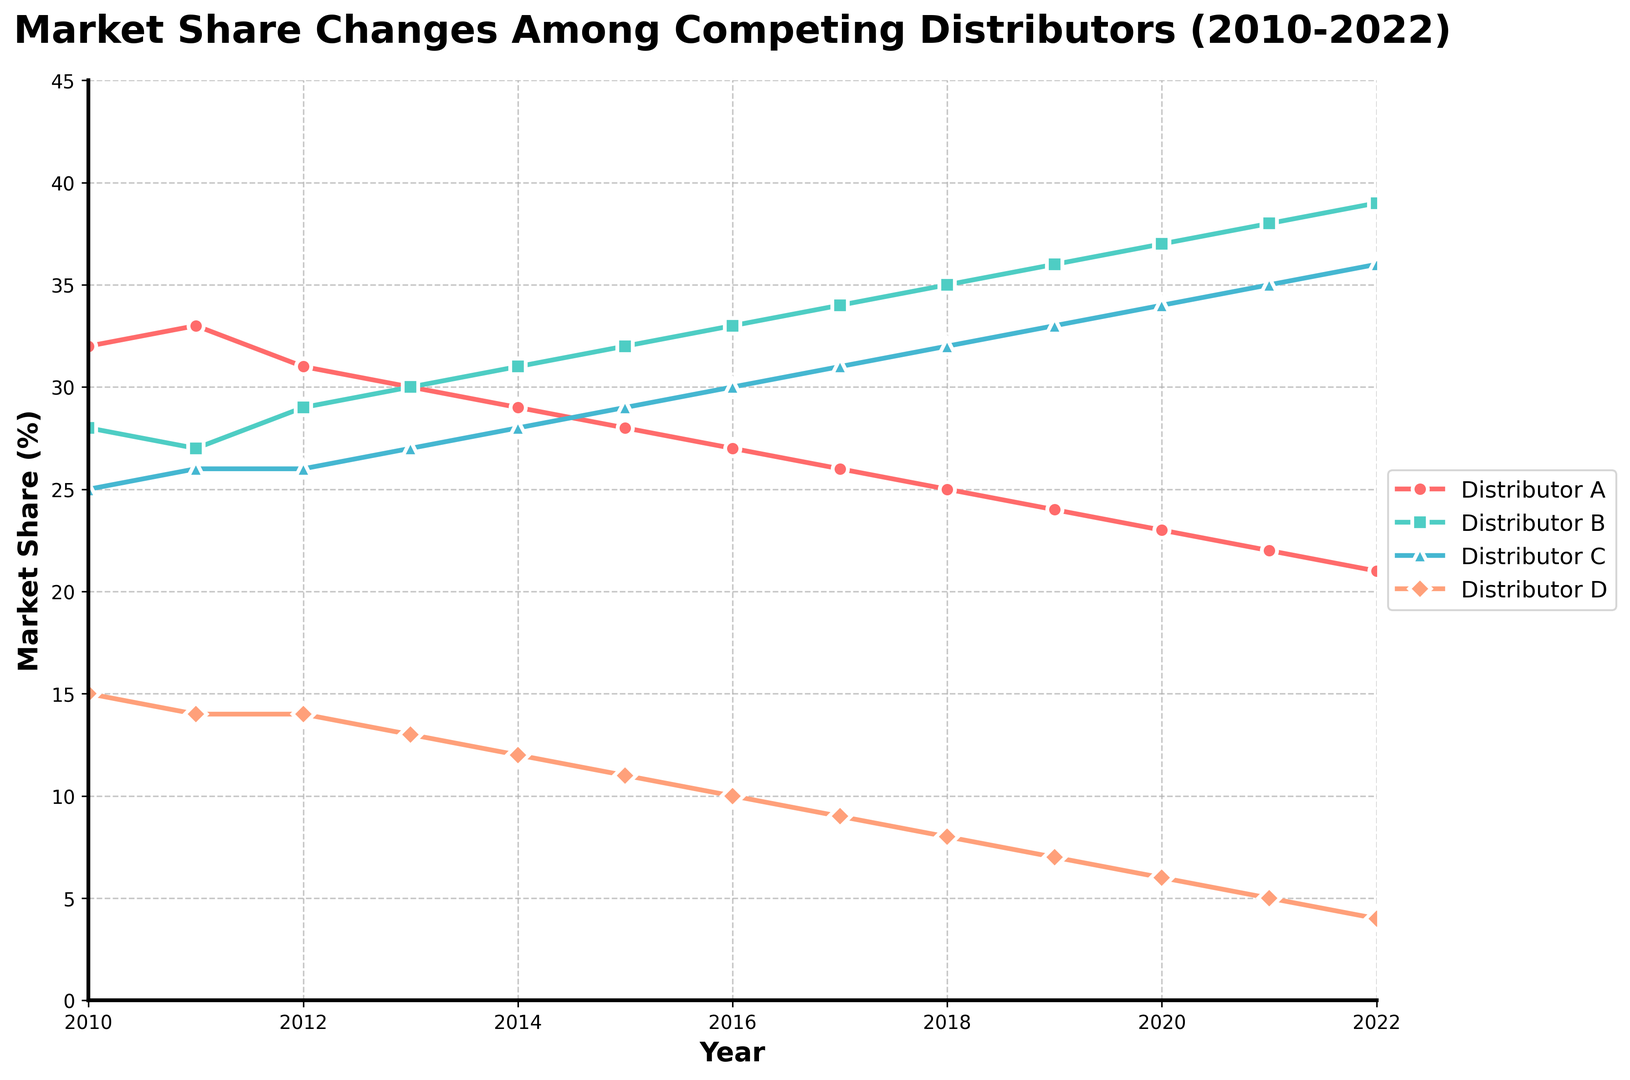What was the market share trend for Distributor A between 2010 and 2022? Distributor A's market share started at 32% in 2010 and consistently decreased each year until it reached 21% in 2022.
Answer: Consistently decreasing Which distributor had the highest market share in 2013, and what was the value? In 2013, Distributor B had the highest market share, with a value of 30%.
Answer: Distributor B, 30% Compare the market shares of Distributor C in 2015 and Distributor D in 2018. Which one was higher and by how much? Distributor C had a market share of 29% in 2015, and Distributor D had a market share of 8% in 2018. The difference is 29% - 8% = 21%.
Answer: Distributor C by 21% What has been the trend for Distributor B from 2010 to 2022? Distributor B's market share increased each year from 28% in 2010 to 39% in 2022.
Answer: Increasing Calculate the average market share of Distributor D from 2010 to 2022. Adding up Distributor D's market share values from 2010 to 2022 gives 15 + 14 + 14 + 13 + 12 + 11 + 10 + 9 + 8 + 7 + 6 + 5 + 4 = 128. There are 13 entries, so the average is 128 / 13 ≈ 9.85.
Answer: 9.85 In which year did Distributor C first surpass Distributor A in market share, and what were their respective shares? In 2014, Distributor C had 28% and Distributor A had 29%. In 2015, Distributor C surpassed Distributor A with 29% whereas Distributor A had 28%.
Answer: 2015, Distributor C: 29%, Distributor A: 28% How much did Distributor D's market share decrease between 2010 and 2022? Distributor D's market share was 15% in 2010 and decreased to 4% in 2022. The decrease is 15% - 4% = 11%.
Answer: 11% Among all four distributors, which one had the most stable market share trend from 2010 to 2022? Distributor C had the most stable trend, increasing steadily from 25% in 2010 to 36% in 2022.
Answer: Distributor C 